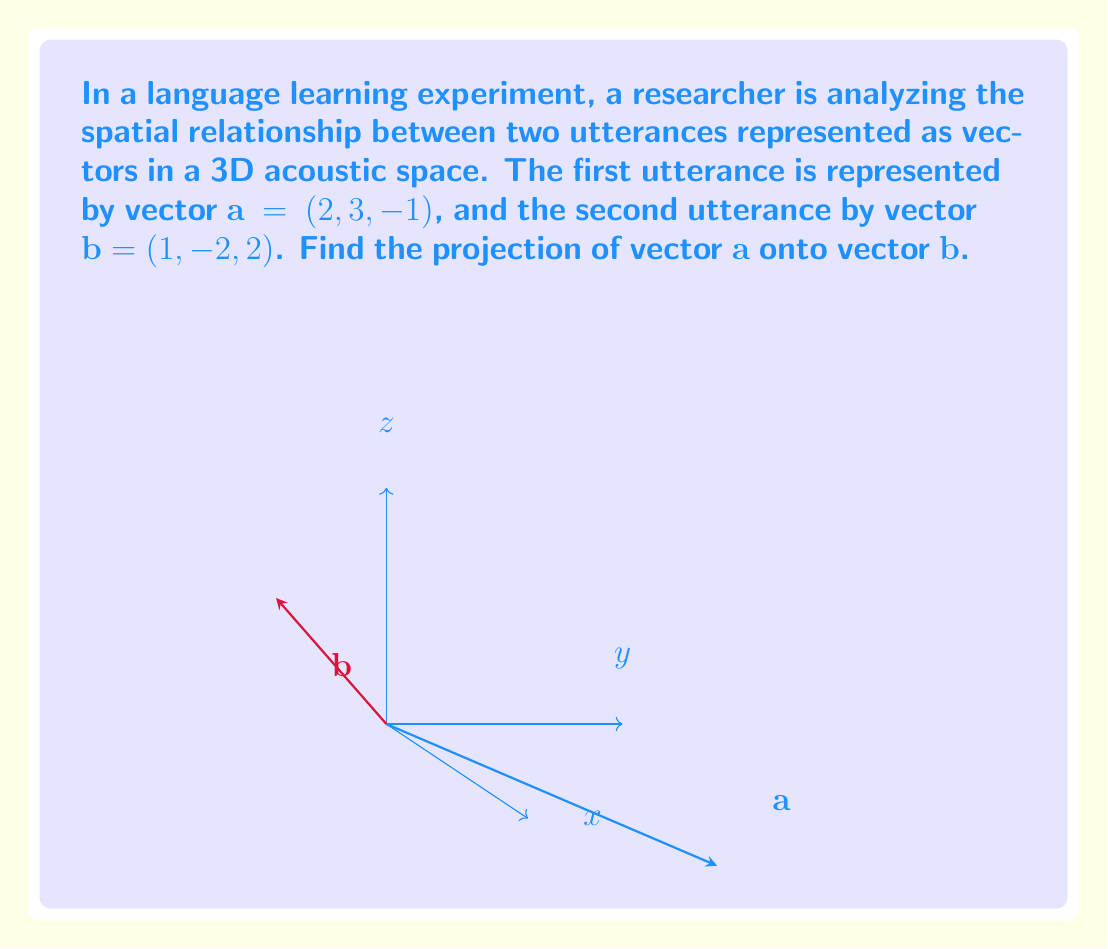Could you help me with this problem? To find the projection of vector $\mathbf{a}$ onto vector $\mathbf{b}$, we'll use the formula:

$$\text{proj}_\mathbf{b} \mathbf{a} = \frac{\mathbf{a} \cdot \mathbf{b}}{\|\mathbf{b}\|^2} \mathbf{b}$$

Step 1: Calculate the dot product $\mathbf{a} \cdot \mathbf{b}$
$$\mathbf{a} \cdot \mathbf{b} = (2)(1) + (3)(-2) + (-1)(2) = 2 - 6 - 2 = -6$$

Step 2: Calculate $\|\mathbf{b}\|^2$
$$\|\mathbf{b}\|^2 = 1^2 + (-2)^2 + 2^2 = 1 + 4 + 4 = 9$$

Step 3: Calculate the scalar projection
$$\frac{\mathbf{a} \cdot \mathbf{b}}{\|\mathbf{b}\|^2} = \frac{-6}{9} = -\frac{2}{3}$$

Step 4: Multiply the scalar projection by $\mathbf{b}$
$$\text{proj}_\mathbf{b} \mathbf{a} = -\frac{2}{3}(1, -2, 2) = \left(-\frac{2}{3}, \frac{4}{3}, -\frac{4}{3}\right)$$
Answer: $\left(-\frac{2}{3}, \frac{4}{3}, -\frac{4}{3}\right)$ 